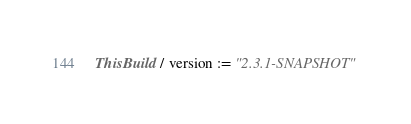Convert code to text. <code><loc_0><loc_0><loc_500><loc_500><_Scala_>ThisBuild / version := "2.3.1-SNAPSHOT"
</code> 